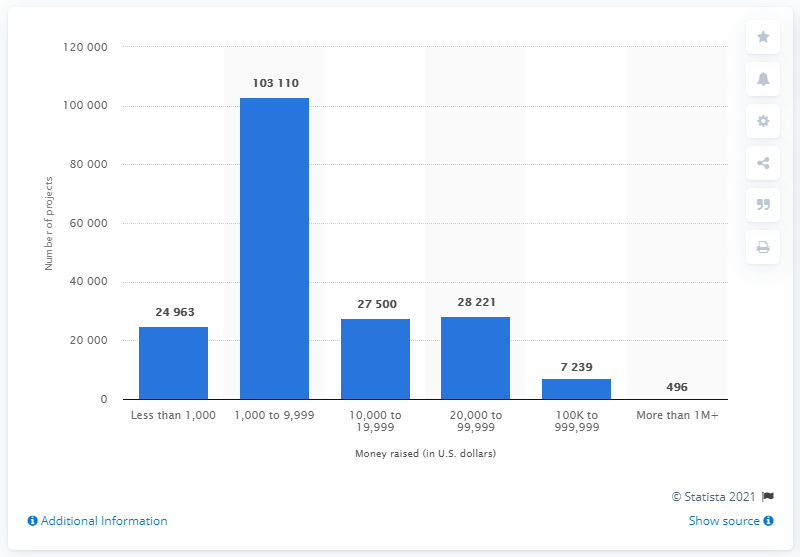Indicate a few pertinent items in this graphic. As of November 10, 2020, 496 successful projects were funded on Kickstarter. 